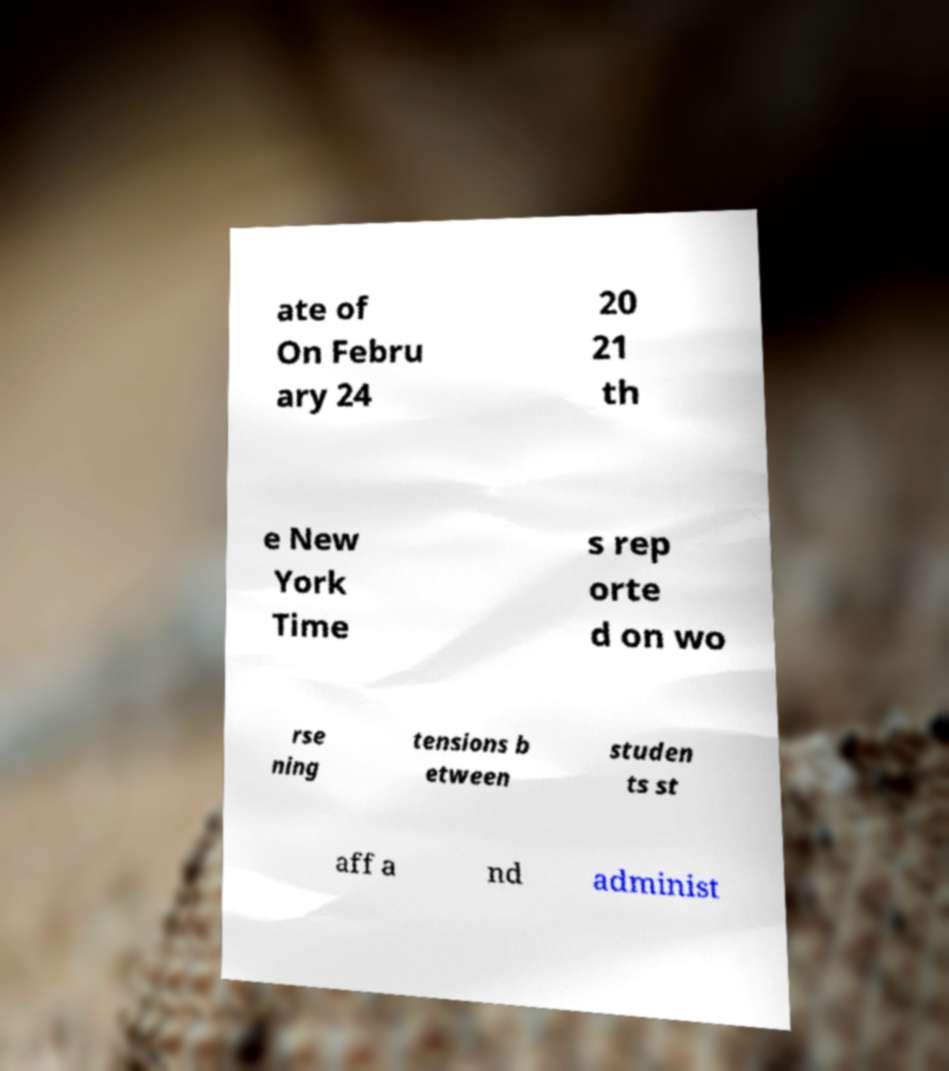Can you accurately transcribe the text from the provided image for me? ate of On Febru ary 24 20 21 th e New York Time s rep orte d on wo rse ning tensions b etween studen ts st aff a nd administ 